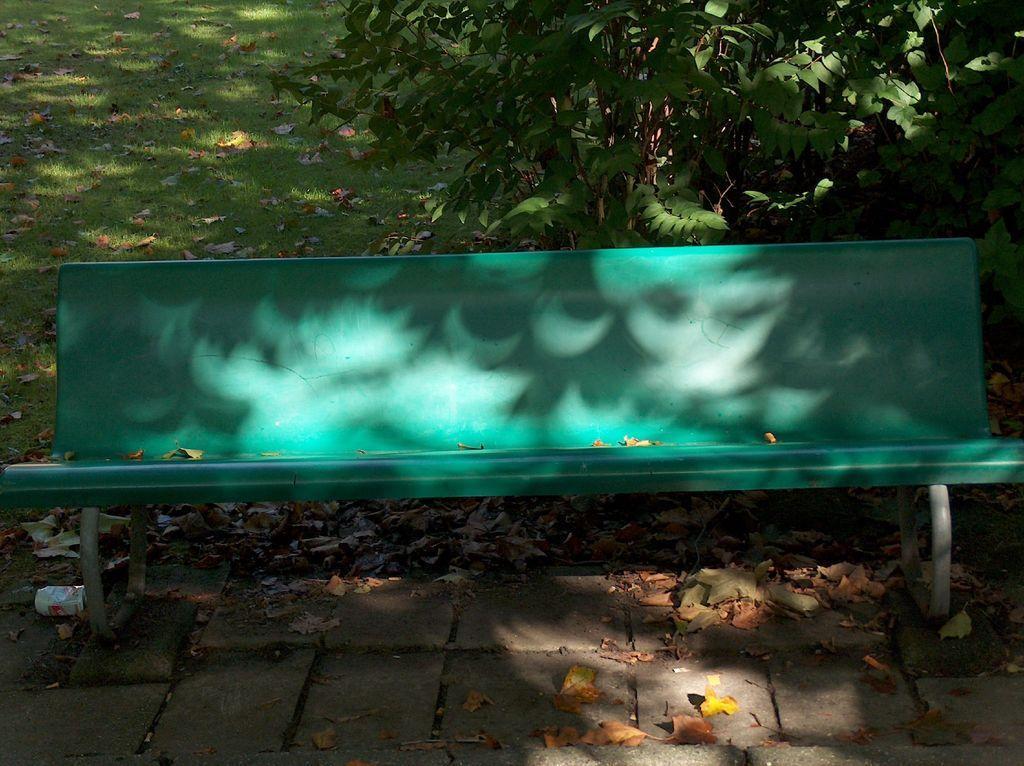Could you give a brief overview of what you see in this image? At the bottom of the image on the floor there are dry leaves. And there is a green bench. Behind the bench there is a tree. On the ground there is grass with dry leaves. 